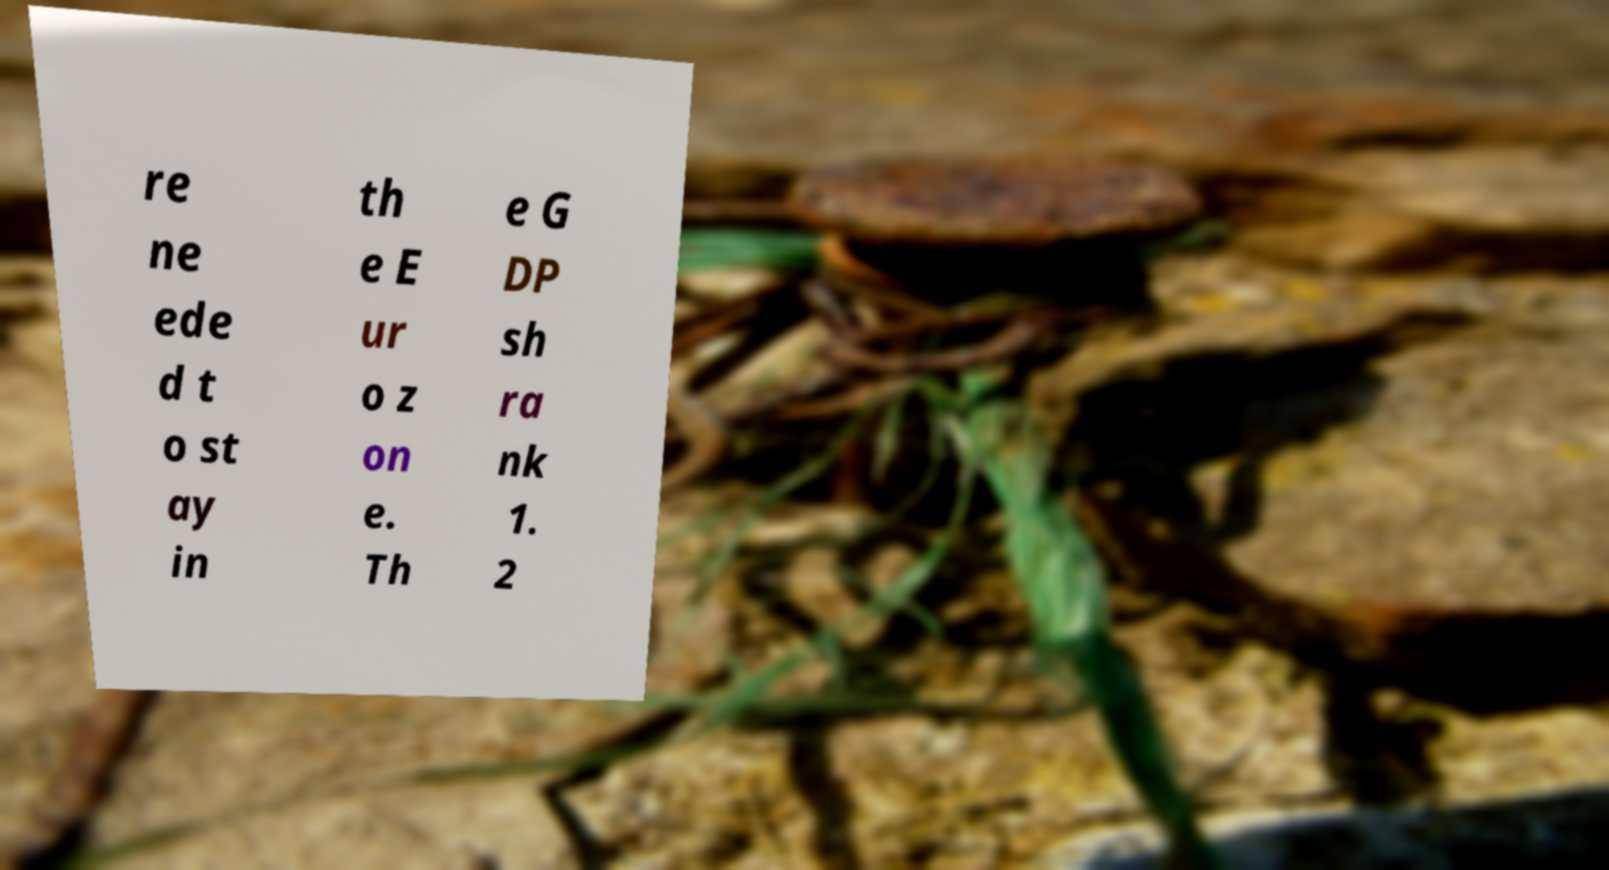For documentation purposes, I need the text within this image transcribed. Could you provide that? re ne ede d t o st ay in th e E ur o z on e. Th e G DP sh ra nk 1. 2 